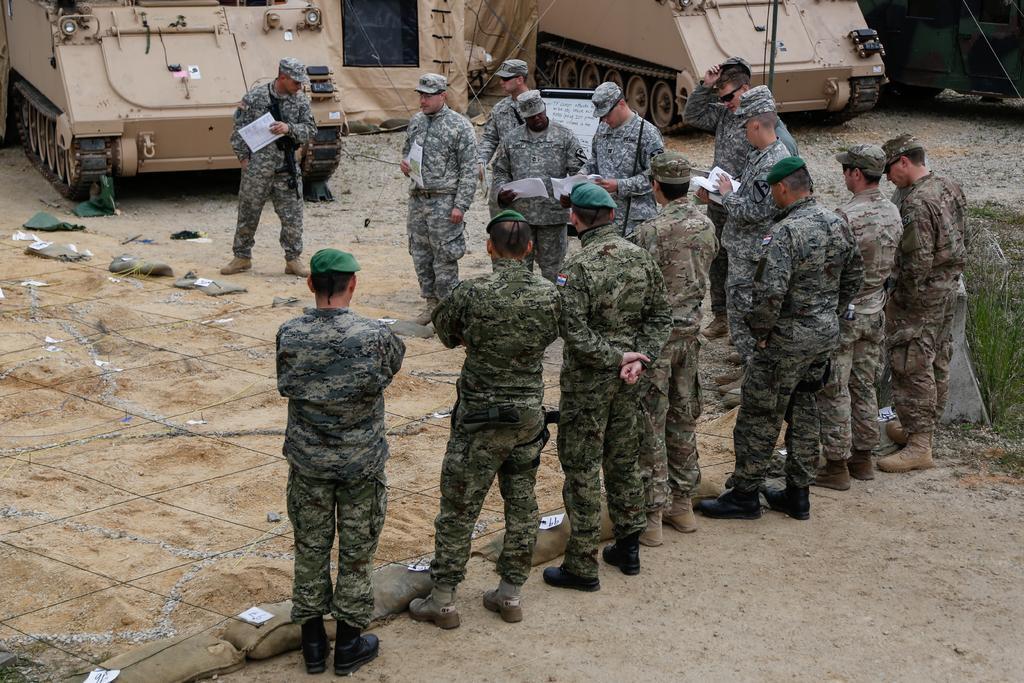How would you summarize this image in a sentence or two? In this image I see number of men who are wearing army uniforms and I see the ground and I see tanks over here and I see the plants over here. 